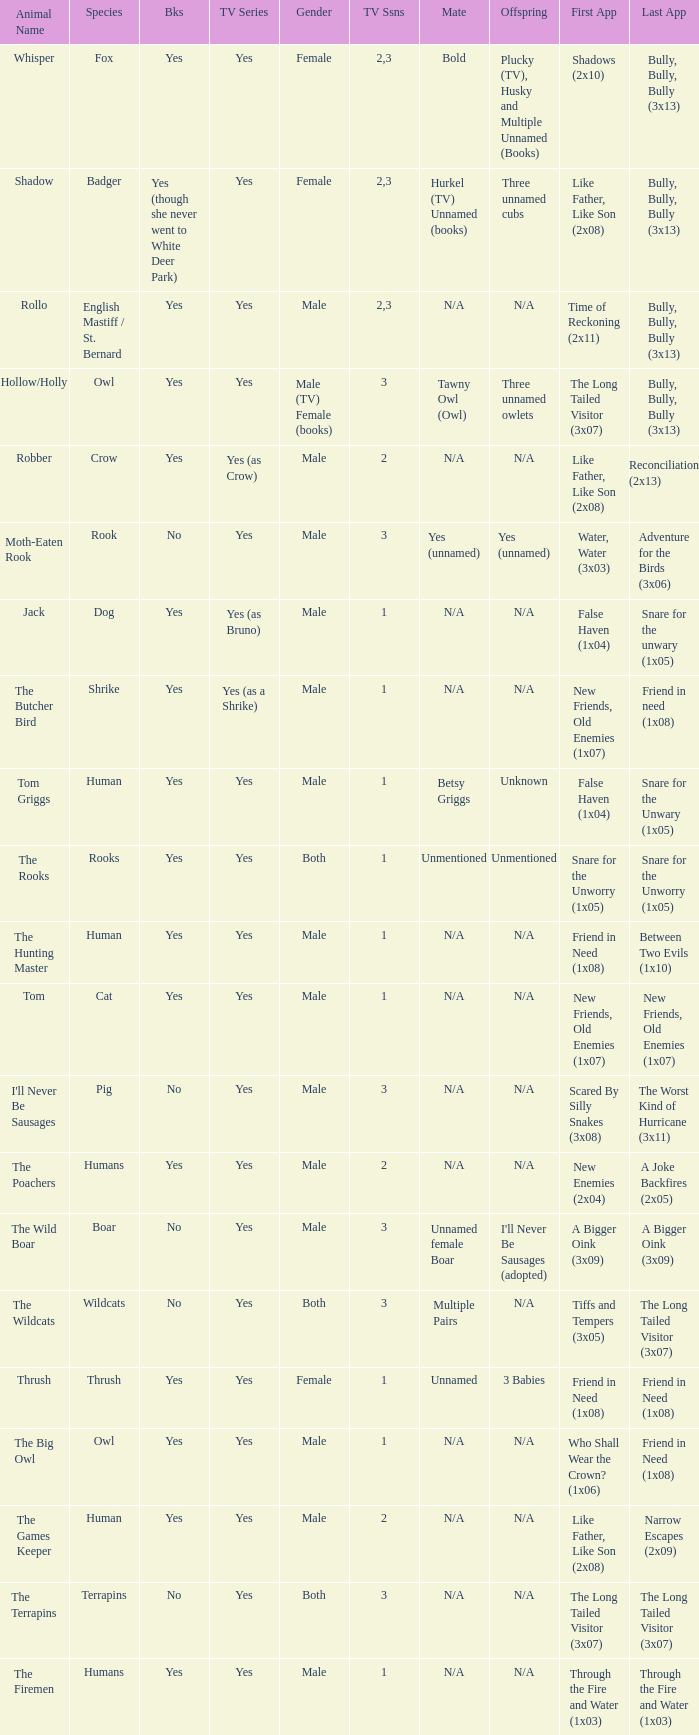What is the shortest season of a tv series that features a human character and has a positive response? 1.0. 